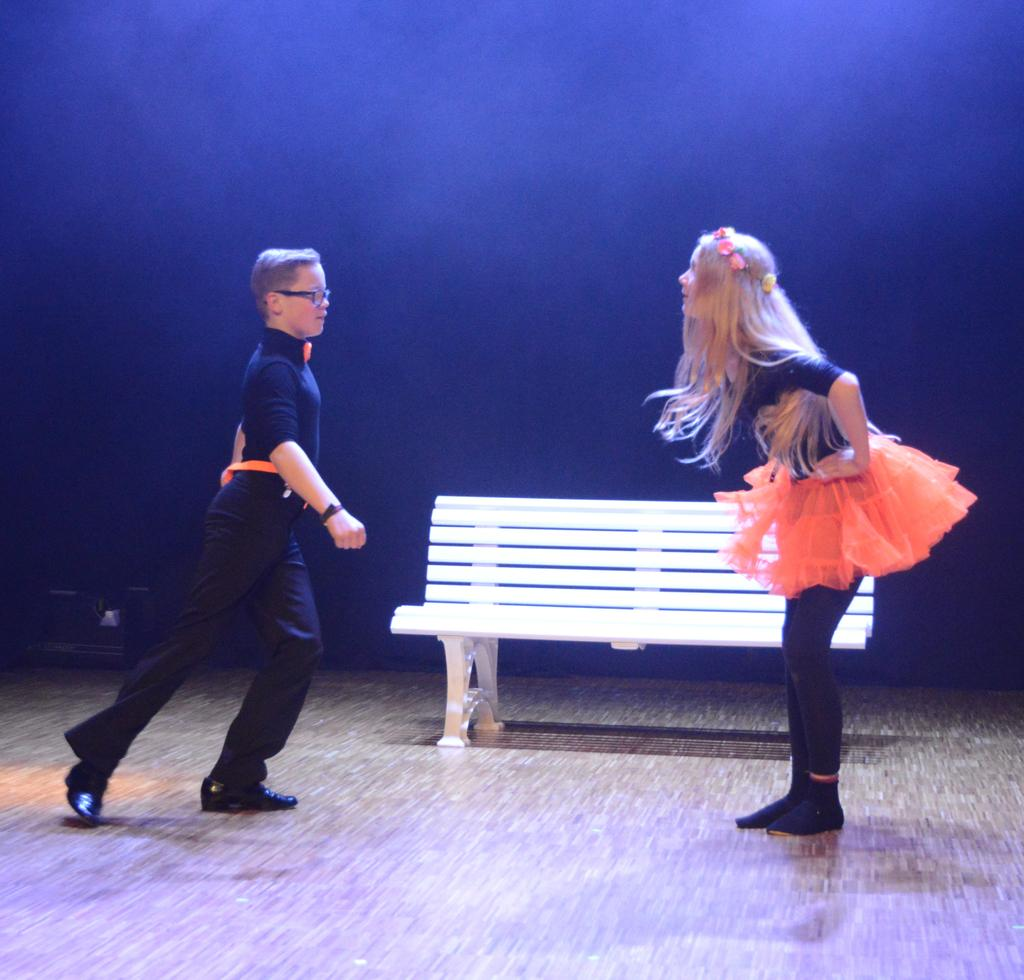What is the gender of the person on the right side of the image? There is a girl on the right side of the image. What is the gender of the person on the left side of the image? There is a boy on the left side of the image. What is in the center of the image? There is a white color bench in the center of the image. What type of education is being taught on the bench in the image? There is no indication of education or teaching in the image; it simply shows a girl, a boy, and a bench. 